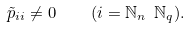Convert formula to latex. <formula><loc_0><loc_0><loc_500><loc_500>\tilde { p } _ { i i } \neq 0 \quad ( i = \mathbb { N } _ { n } \ \mathbb { N } _ { q } ) .</formula> 